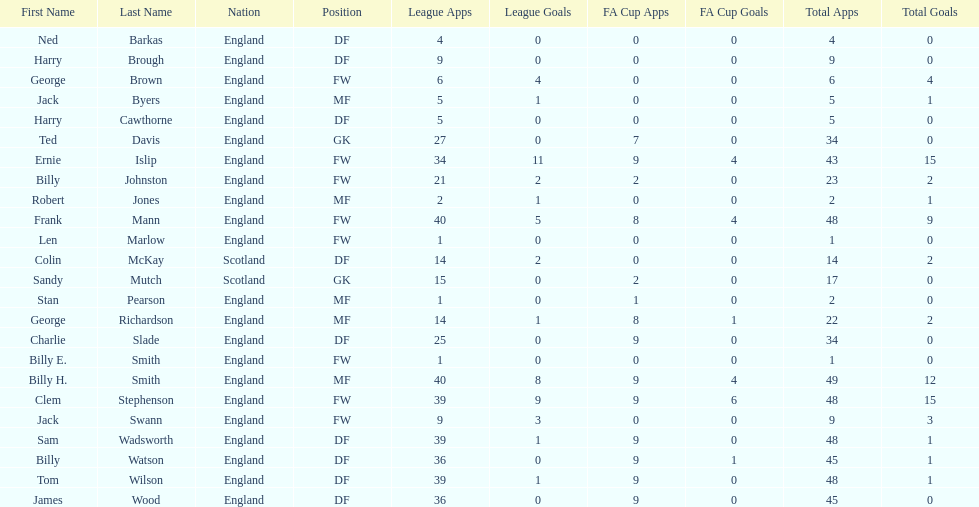Average number of goals scored by players from scotland 1. 